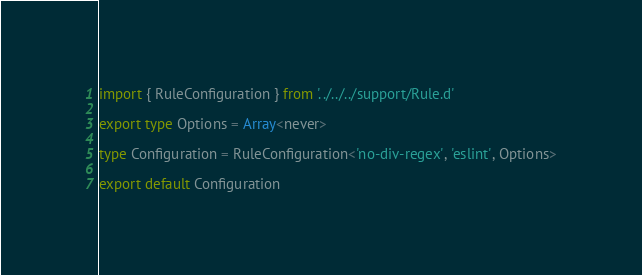Convert code to text. <code><loc_0><loc_0><loc_500><loc_500><_TypeScript_>import { RuleConfiguration } from '../../../support/Rule.d'

export type Options = Array<never>

type Configuration = RuleConfiguration<'no-div-regex', 'eslint', Options>

export default Configuration
</code> 